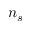<formula> <loc_0><loc_0><loc_500><loc_500>n _ { s }</formula> 